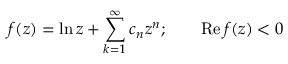<formula> <loc_0><loc_0><loc_500><loc_500>f ( z ) = \ln z + \sum _ { k = 1 } ^ { \infty } c _ { n } z ^ { n } ; \quad R e \, f ( z ) < 0</formula> 